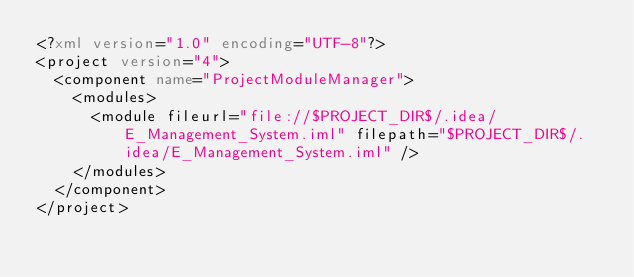<code> <loc_0><loc_0><loc_500><loc_500><_XML_><?xml version="1.0" encoding="UTF-8"?>
<project version="4">
  <component name="ProjectModuleManager">
    <modules>
      <module fileurl="file://$PROJECT_DIR$/.idea/E_Management_System.iml" filepath="$PROJECT_DIR$/.idea/E_Management_System.iml" />
    </modules>
  </component>
</project></code> 